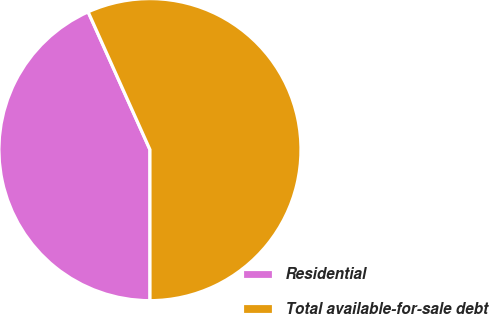Convert chart. <chart><loc_0><loc_0><loc_500><loc_500><pie_chart><fcel>Residential<fcel>Total available-for-sale debt<nl><fcel>43.29%<fcel>56.71%<nl></chart> 